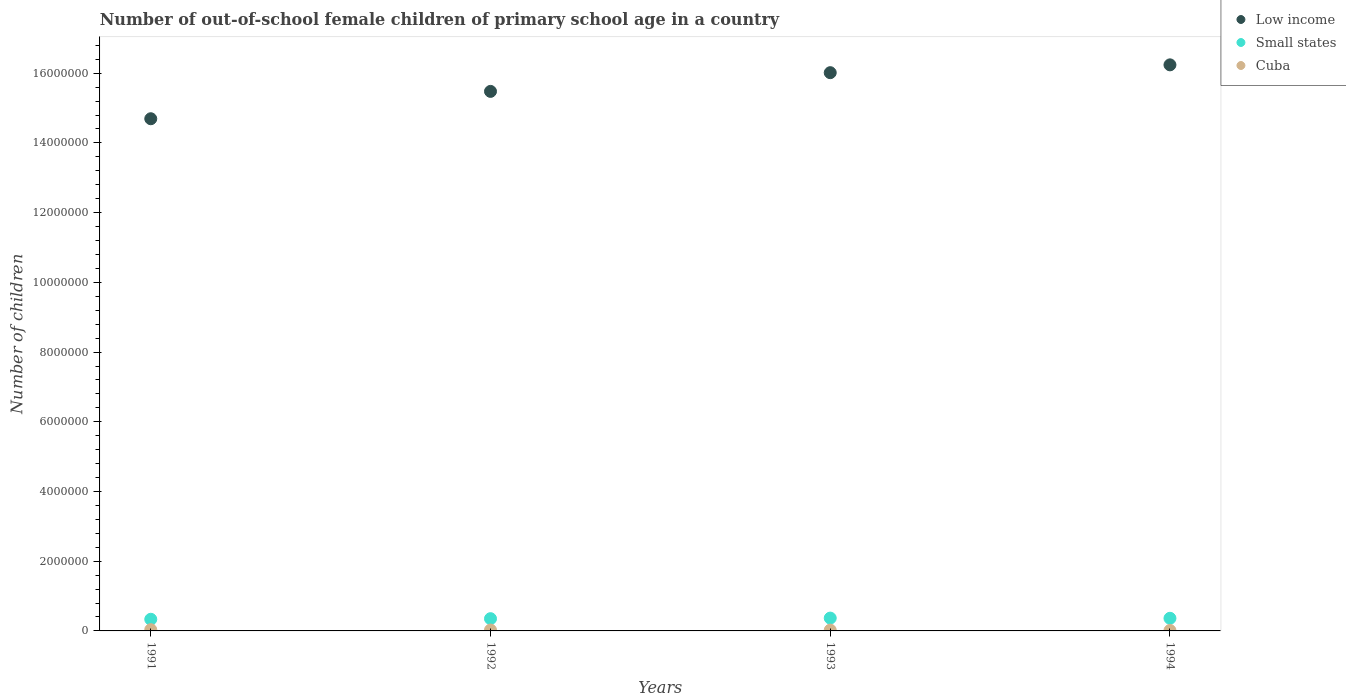How many different coloured dotlines are there?
Offer a terse response. 3. What is the number of out-of-school female children in Small states in 1994?
Provide a short and direct response. 3.62e+05. Across all years, what is the maximum number of out-of-school female children in Low income?
Provide a succinct answer. 1.62e+07. Across all years, what is the minimum number of out-of-school female children in Small states?
Keep it short and to the point. 3.34e+05. In which year was the number of out-of-school female children in Cuba maximum?
Offer a terse response. 1991. In which year was the number of out-of-school female children in Small states minimum?
Your response must be concise. 1991. What is the total number of out-of-school female children in Low income in the graph?
Keep it short and to the point. 6.24e+07. What is the difference between the number of out-of-school female children in Small states in 1991 and that in 1993?
Your answer should be very brief. -3.39e+04. What is the difference between the number of out-of-school female children in Low income in 1991 and the number of out-of-school female children in Cuba in 1992?
Offer a very short reply. 1.47e+07. What is the average number of out-of-school female children in Small states per year?
Ensure brevity in your answer.  3.54e+05. In the year 1994, what is the difference between the number of out-of-school female children in Cuba and number of out-of-school female children in Low income?
Make the answer very short. -1.62e+07. In how many years, is the number of out-of-school female children in Cuba greater than 2000000?
Offer a very short reply. 0. What is the ratio of the number of out-of-school female children in Cuba in 1992 to that in 1993?
Provide a short and direct response. 1.12. Is the number of out-of-school female children in Cuba in 1991 less than that in 1993?
Your answer should be very brief. No. What is the difference between the highest and the second highest number of out-of-school female children in Low income?
Give a very brief answer. 2.24e+05. What is the difference between the highest and the lowest number of out-of-school female children in Small states?
Provide a succinct answer. 3.39e+04. Is the sum of the number of out-of-school female children in Cuba in 1993 and 1994 greater than the maximum number of out-of-school female children in Low income across all years?
Offer a terse response. No. How many years are there in the graph?
Offer a very short reply. 4. What is the difference between two consecutive major ticks on the Y-axis?
Provide a short and direct response. 2.00e+06. Does the graph contain any zero values?
Make the answer very short. No. Where does the legend appear in the graph?
Offer a terse response. Top right. What is the title of the graph?
Your answer should be very brief. Number of out-of-school female children of primary school age in a country. Does "Turkey" appear as one of the legend labels in the graph?
Offer a terse response. No. What is the label or title of the Y-axis?
Offer a very short reply. Number of children. What is the Number of children in Low income in 1991?
Ensure brevity in your answer.  1.47e+07. What is the Number of children in Small states in 1991?
Your response must be concise. 3.34e+05. What is the Number of children in Cuba in 1991?
Ensure brevity in your answer.  3.55e+04. What is the Number of children of Low income in 1992?
Your response must be concise. 1.55e+07. What is the Number of children in Small states in 1992?
Provide a short and direct response. 3.51e+05. What is the Number of children of Cuba in 1992?
Provide a succinct answer. 2.56e+04. What is the Number of children in Low income in 1993?
Your answer should be very brief. 1.60e+07. What is the Number of children in Small states in 1993?
Your answer should be very brief. 3.68e+05. What is the Number of children in Cuba in 1993?
Your answer should be compact. 2.29e+04. What is the Number of children in Low income in 1994?
Give a very brief answer. 1.62e+07. What is the Number of children of Small states in 1994?
Your answer should be very brief. 3.62e+05. What is the Number of children of Cuba in 1994?
Offer a very short reply. 1.30e+04. Across all years, what is the maximum Number of children of Low income?
Provide a succinct answer. 1.62e+07. Across all years, what is the maximum Number of children in Small states?
Offer a terse response. 3.68e+05. Across all years, what is the maximum Number of children of Cuba?
Your answer should be compact. 3.55e+04. Across all years, what is the minimum Number of children in Low income?
Provide a succinct answer. 1.47e+07. Across all years, what is the minimum Number of children in Small states?
Keep it short and to the point. 3.34e+05. Across all years, what is the minimum Number of children in Cuba?
Keep it short and to the point. 1.30e+04. What is the total Number of children in Low income in the graph?
Provide a short and direct response. 6.24e+07. What is the total Number of children of Small states in the graph?
Make the answer very short. 1.42e+06. What is the total Number of children of Cuba in the graph?
Give a very brief answer. 9.70e+04. What is the difference between the Number of children of Low income in 1991 and that in 1992?
Ensure brevity in your answer.  -7.85e+05. What is the difference between the Number of children of Small states in 1991 and that in 1992?
Your answer should be very brief. -1.72e+04. What is the difference between the Number of children in Cuba in 1991 and that in 1992?
Offer a terse response. 9887. What is the difference between the Number of children of Low income in 1991 and that in 1993?
Your answer should be very brief. -1.32e+06. What is the difference between the Number of children in Small states in 1991 and that in 1993?
Ensure brevity in your answer.  -3.39e+04. What is the difference between the Number of children in Cuba in 1991 and that in 1993?
Offer a terse response. 1.25e+04. What is the difference between the Number of children of Low income in 1991 and that in 1994?
Offer a terse response. -1.55e+06. What is the difference between the Number of children of Small states in 1991 and that in 1994?
Your answer should be compact. -2.85e+04. What is the difference between the Number of children of Cuba in 1991 and that in 1994?
Provide a succinct answer. 2.25e+04. What is the difference between the Number of children of Low income in 1992 and that in 1993?
Make the answer very short. -5.37e+05. What is the difference between the Number of children in Small states in 1992 and that in 1993?
Make the answer very short. -1.67e+04. What is the difference between the Number of children in Cuba in 1992 and that in 1993?
Provide a short and direct response. 2642. What is the difference between the Number of children in Low income in 1992 and that in 1994?
Your answer should be very brief. -7.61e+05. What is the difference between the Number of children in Small states in 1992 and that in 1994?
Ensure brevity in your answer.  -1.13e+04. What is the difference between the Number of children in Cuba in 1992 and that in 1994?
Provide a short and direct response. 1.26e+04. What is the difference between the Number of children in Low income in 1993 and that in 1994?
Make the answer very short. -2.24e+05. What is the difference between the Number of children of Small states in 1993 and that in 1994?
Your answer should be very brief. 5384. What is the difference between the Number of children of Cuba in 1993 and that in 1994?
Your answer should be very brief. 9922. What is the difference between the Number of children in Low income in 1991 and the Number of children in Small states in 1992?
Give a very brief answer. 1.43e+07. What is the difference between the Number of children of Low income in 1991 and the Number of children of Cuba in 1992?
Keep it short and to the point. 1.47e+07. What is the difference between the Number of children of Small states in 1991 and the Number of children of Cuba in 1992?
Offer a very short reply. 3.08e+05. What is the difference between the Number of children in Low income in 1991 and the Number of children in Small states in 1993?
Give a very brief answer. 1.43e+07. What is the difference between the Number of children of Low income in 1991 and the Number of children of Cuba in 1993?
Your answer should be very brief. 1.47e+07. What is the difference between the Number of children of Small states in 1991 and the Number of children of Cuba in 1993?
Provide a short and direct response. 3.11e+05. What is the difference between the Number of children of Low income in 1991 and the Number of children of Small states in 1994?
Make the answer very short. 1.43e+07. What is the difference between the Number of children in Low income in 1991 and the Number of children in Cuba in 1994?
Offer a terse response. 1.47e+07. What is the difference between the Number of children in Small states in 1991 and the Number of children in Cuba in 1994?
Your response must be concise. 3.21e+05. What is the difference between the Number of children in Low income in 1992 and the Number of children in Small states in 1993?
Provide a short and direct response. 1.51e+07. What is the difference between the Number of children of Low income in 1992 and the Number of children of Cuba in 1993?
Ensure brevity in your answer.  1.55e+07. What is the difference between the Number of children of Small states in 1992 and the Number of children of Cuba in 1993?
Offer a very short reply. 3.28e+05. What is the difference between the Number of children in Low income in 1992 and the Number of children in Small states in 1994?
Your answer should be compact. 1.51e+07. What is the difference between the Number of children in Low income in 1992 and the Number of children in Cuba in 1994?
Ensure brevity in your answer.  1.55e+07. What is the difference between the Number of children in Small states in 1992 and the Number of children in Cuba in 1994?
Your answer should be very brief. 3.38e+05. What is the difference between the Number of children of Low income in 1993 and the Number of children of Small states in 1994?
Your answer should be compact. 1.57e+07. What is the difference between the Number of children of Low income in 1993 and the Number of children of Cuba in 1994?
Offer a very short reply. 1.60e+07. What is the difference between the Number of children of Small states in 1993 and the Number of children of Cuba in 1994?
Keep it short and to the point. 3.55e+05. What is the average Number of children of Low income per year?
Your answer should be very brief. 1.56e+07. What is the average Number of children in Small states per year?
Offer a very short reply. 3.54e+05. What is the average Number of children in Cuba per year?
Keep it short and to the point. 2.42e+04. In the year 1991, what is the difference between the Number of children of Low income and Number of children of Small states?
Your response must be concise. 1.44e+07. In the year 1991, what is the difference between the Number of children of Low income and Number of children of Cuba?
Provide a short and direct response. 1.47e+07. In the year 1991, what is the difference between the Number of children in Small states and Number of children in Cuba?
Your answer should be compact. 2.99e+05. In the year 1992, what is the difference between the Number of children of Low income and Number of children of Small states?
Provide a short and direct response. 1.51e+07. In the year 1992, what is the difference between the Number of children in Low income and Number of children in Cuba?
Offer a terse response. 1.55e+07. In the year 1992, what is the difference between the Number of children in Small states and Number of children in Cuba?
Give a very brief answer. 3.26e+05. In the year 1993, what is the difference between the Number of children in Low income and Number of children in Small states?
Your answer should be very brief. 1.56e+07. In the year 1993, what is the difference between the Number of children of Low income and Number of children of Cuba?
Provide a short and direct response. 1.60e+07. In the year 1993, what is the difference between the Number of children of Small states and Number of children of Cuba?
Your answer should be compact. 3.45e+05. In the year 1994, what is the difference between the Number of children in Low income and Number of children in Small states?
Your response must be concise. 1.59e+07. In the year 1994, what is the difference between the Number of children in Low income and Number of children in Cuba?
Keep it short and to the point. 1.62e+07. In the year 1994, what is the difference between the Number of children of Small states and Number of children of Cuba?
Offer a very short reply. 3.49e+05. What is the ratio of the Number of children of Low income in 1991 to that in 1992?
Make the answer very short. 0.95. What is the ratio of the Number of children in Small states in 1991 to that in 1992?
Provide a short and direct response. 0.95. What is the ratio of the Number of children in Cuba in 1991 to that in 1992?
Your answer should be very brief. 1.39. What is the ratio of the Number of children in Low income in 1991 to that in 1993?
Your answer should be compact. 0.92. What is the ratio of the Number of children of Small states in 1991 to that in 1993?
Keep it short and to the point. 0.91. What is the ratio of the Number of children in Cuba in 1991 to that in 1993?
Provide a short and direct response. 1.55. What is the ratio of the Number of children in Low income in 1991 to that in 1994?
Your response must be concise. 0.9. What is the ratio of the Number of children of Small states in 1991 to that in 1994?
Keep it short and to the point. 0.92. What is the ratio of the Number of children of Cuba in 1991 to that in 1994?
Offer a very short reply. 2.73. What is the ratio of the Number of children in Low income in 1992 to that in 1993?
Offer a very short reply. 0.97. What is the ratio of the Number of children of Small states in 1992 to that in 1993?
Offer a very short reply. 0.95. What is the ratio of the Number of children in Cuba in 1992 to that in 1993?
Your answer should be compact. 1.12. What is the ratio of the Number of children of Low income in 1992 to that in 1994?
Make the answer very short. 0.95. What is the ratio of the Number of children in Small states in 1992 to that in 1994?
Provide a short and direct response. 0.97. What is the ratio of the Number of children in Cuba in 1992 to that in 1994?
Make the answer very short. 1.97. What is the ratio of the Number of children of Low income in 1993 to that in 1994?
Provide a succinct answer. 0.99. What is the ratio of the Number of children of Small states in 1993 to that in 1994?
Provide a succinct answer. 1.01. What is the ratio of the Number of children in Cuba in 1993 to that in 1994?
Give a very brief answer. 1.76. What is the difference between the highest and the second highest Number of children in Low income?
Provide a succinct answer. 2.24e+05. What is the difference between the highest and the second highest Number of children in Small states?
Your answer should be very brief. 5384. What is the difference between the highest and the second highest Number of children in Cuba?
Ensure brevity in your answer.  9887. What is the difference between the highest and the lowest Number of children in Low income?
Provide a short and direct response. 1.55e+06. What is the difference between the highest and the lowest Number of children in Small states?
Your answer should be compact. 3.39e+04. What is the difference between the highest and the lowest Number of children in Cuba?
Ensure brevity in your answer.  2.25e+04. 